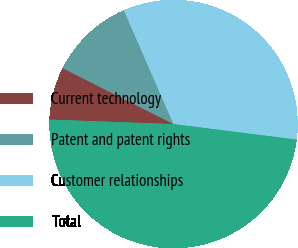Convert chart to OTSL. <chart><loc_0><loc_0><loc_500><loc_500><pie_chart><fcel>Current technology<fcel>Patent and patent rights<fcel>Customer relationships<fcel>Total<nl><fcel>6.85%<fcel>11.02%<fcel>33.54%<fcel>48.59%<nl></chart> 